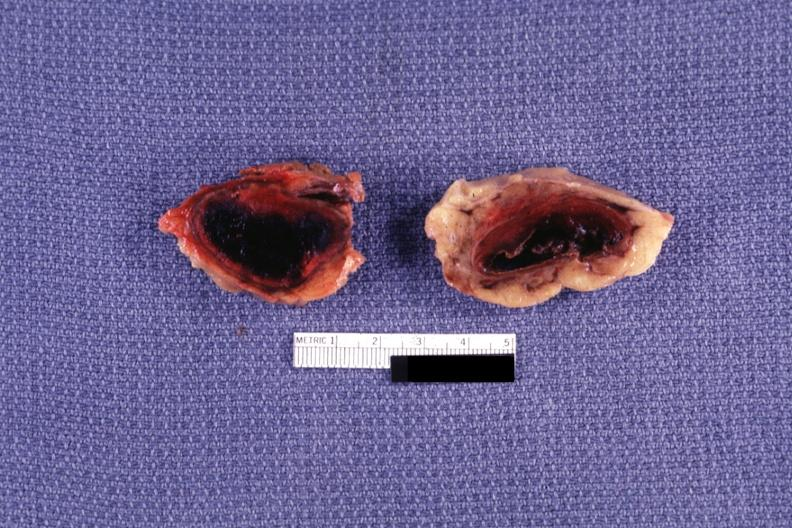what is present?
Answer the question using a single word or phrase. Adrenal 